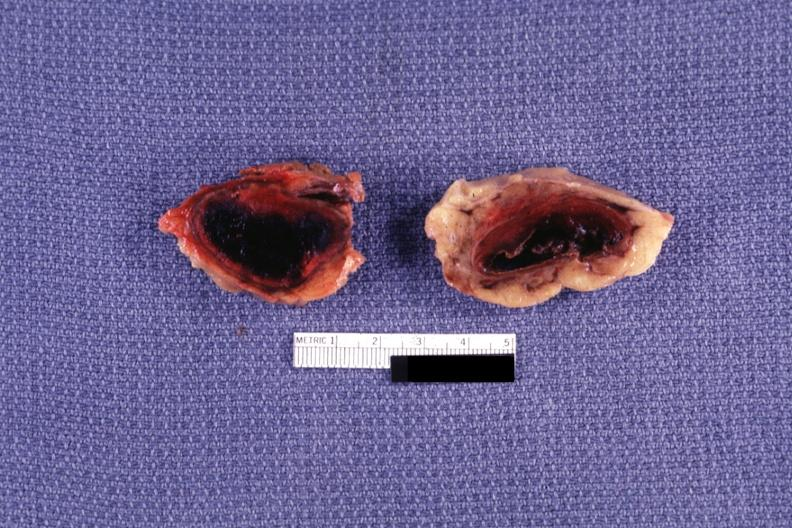what is present?
Answer the question using a single word or phrase. Adrenal 